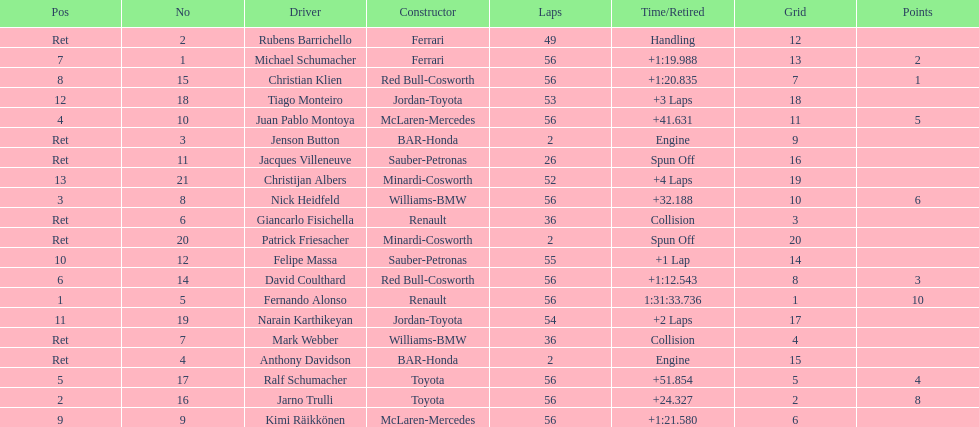How many bmw vehicles completed the race ahead of webber? 1. 